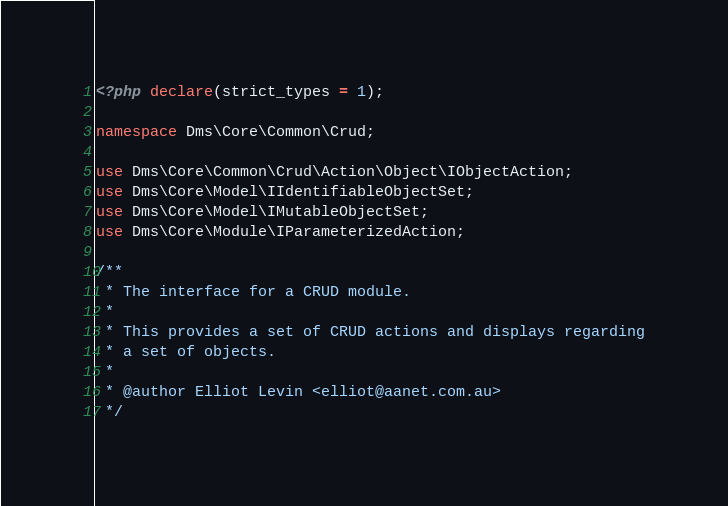Convert code to text. <code><loc_0><loc_0><loc_500><loc_500><_PHP_><?php declare(strict_types = 1);

namespace Dms\Core\Common\Crud;

use Dms\Core\Common\Crud\Action\Object\IObjectAction;
use Dms\Core\Model\IIdentifiableObjectSet;
use Dms\Core\Model\IMutableObjectSet;
use Dms\Core\Module\IParameterizedAction;

/**
 * The interface for a CRUD module.
 *
 * This provides a set of CRUD actions and displays regarding
 * a set of objects.
 *
 * @author Elliot Levin <elliot@aanet.com.au>
 */</code> 